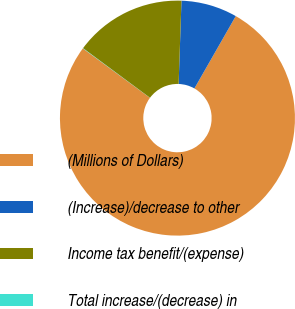Convert chart to OTSL. <chart><loc_0><loc_0><loc_500><loc_500><pie_chart><fcel>(Millions of Dollars)<fcel>(Increase)/decrease to other<fcel>Income tax benefit/(expense)<fcel>Total increase/(decrease) in<nl><fcel>76.84%<fcel>7.72%<fcel>15.4%<fcel>0.04%<nl></chart> 